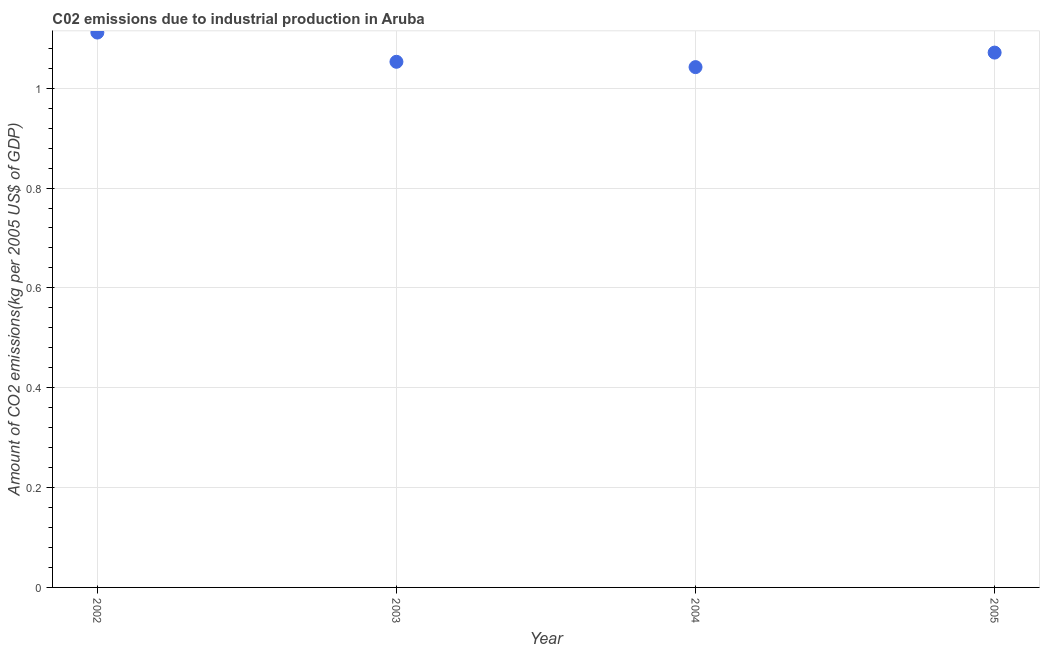What is the amount of co2 emissions in 2005?
Provide a succinct answer. 1.07. Across all years, what is the maximum amount of co2 emissions?
Make the answer very short. 1.11. Across all years, what is the minimum amount of co2 emissions?
Offer a terse response. 1.04. In which year was the amount of co2 emissions maximum?
Give a very brief answer. 2002. In which year was the amount of co2 emissions minimum?
Your response must be concise. 2004. What is the sum of the amount of co2 emissions?
Make the answer very short. 4.28. What is the difference between the amount of co2 emissions in 2003 and 2005?
Ensure brevity in your answer.  -0.02. What is the average amount of co2 emissions per year?
Offer a terse response. 1.07. What is the median amount of co2 emissions?
Provide a succinct answer. 1.06. What is the ratio of the amount of co2 emissions in 2002 to that in 2003?
Offer a very short reply. 1.06. What is the difference between the highest and the second highest amount of co2 emissions?
Give a very brief answer. 0.04. What is the difference between the highest and the lowest amount of co2 emissions?
Ensure brevity in your answer.  0.07. In how many years, is the amount of co2 emissions greater than the average amount of co2 emissions taken over all years?
Give a very brief answer. 2. Does the amount of co2 emissions monotonically increase over the years?
Keep it short and to the point. No. How many dotlines are there?
Your answer should be compact. 1. What is the difference between two consecutive major ticks on the Y-axis?
Offer a very short reply. 0.2. Are the values on the major ticks of Y-axis written in scientific E-notation?
Offer a very short reply. No. Does the graph contain any zero values?
Give a very brief answer. No. What is the title of the graph?
Ensure brevity in your answer.  C02 emissions due to industrial production in Aruba. What is the label or title of the Y-axis?
Your answer should be very brief. Amount of CO2 emissions(kg per 2005 US$ of GDP). What is the Amount of CO2 emissions(kg per 2005 US$ of GDP) in 2002?
Keep it short and to the point. 1.11. What is the Amount of CO2 emissions(kg per 2005 US$ of GDP) in 2003?
Your answer should be compact. 1.05. What is the Amount of CO2 emissions(kg per 2005 US$ of GDP) in 2004?
Your response must be concise. 1.04. What is the Amount of CO2 emissions(kg per 2005 US$ of GDP) in 2005?
Provide a succinct answer. 1.07. What is the difference between the Amount of CO2 emissions(kg per 2005 US$ of GDP) in 2002 and 2003?
Provide a succinct answer. 0.06. What is the difference between the Amount of CO2 emissions(kg per 2005 US$ of GDP) in 2002 and 2004?
Ensure brevity in your answer.  0.07. What is the difference between the Amount of CO2 emissions(kg per 2005 US$ of GDP) in 2002 and 2005?
Provide a succinct answer. 0.04. What is the difference between the Amount of CO2 emissions(kg per 2005 US$ of GDP) in 2003 and 2004?
Your answer should be compact. 0.01. What is the difference between the Amount of CO2 emissions(kg per 2005 US$ of GDP) in 2003 and 2005?
Offer a very short reply. -0.02. What is the difference between the Amount of CO2 emissions(kg per 2005 US$ of GDP) in 2004 and 2005?
Your response must be concise. -0.03. What is the ratio of the Amount of CO2 emissions(kg per 2005 US$ of GDP) in 2002 to that in 2003?
Your answer should be compact. 1.06. What is the ratio of the Amount of CO2 emissions(kg per 2005 US$ of GDP) in 2002 to that in 2004?
Provide a short and direct response. 1.07. What is the ratio of the Amount of CO2 emissions(kg per 2005 US$ of GDP) in 2003 to that in 2004?
Offer a very short reply. 1.01. What is the ratio of the Amount of CO2 emissions(kg per 2005 US$ of GDP) in 2003 to that in 2005?
Give a very brief answer. 0.98. 